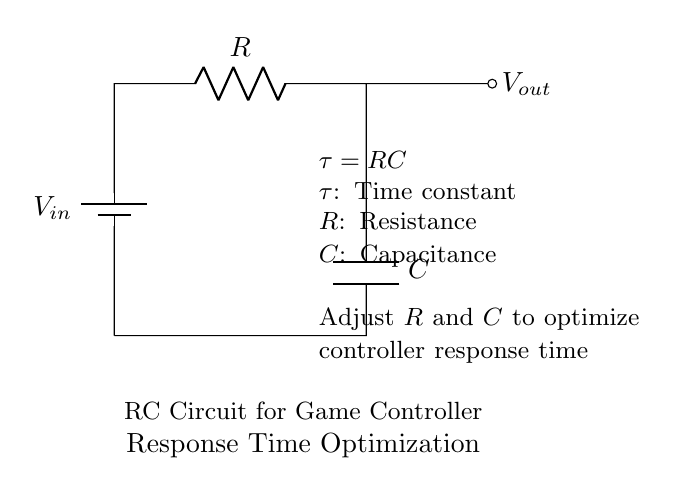What components are present in the circuit? The circuit contains a battery, a resistor, and a capacitor.
Answer: battery, resistor, capacitor What does the symbol "C" represent in the circuit? In this RC circuit, "C" represents the capacitance of the capacitor, which affects how long it takes to charge and discharge the capacitor.
Answer: capacitance What is the formula for the time constant in an RC circuit? The time constant is represented by the formula tau equals R multiplied by C, where R is the resistance and C is the capacitance.
Answer: tau equals RC How can changing the resistor value affect the circuit response time? Increasing the resistor value will increase the time constant, resulting in a slower response time; decreasing it will do the opposite.
Answer: slower response time What is the effect of increasing capacitance on the circuit response time? Increasing capacitance also increases the time constant, leading to a longer time for the capacitor to charge or discharge and a slower response time.
Answer: slower response time What is the purpose of the RC circuit in game controller optimization? The RC circuit is used to adjust and optimize the response time of a game controller, ensuring more accurate and timely reactions to user inputs.
Answer: optimize response time 